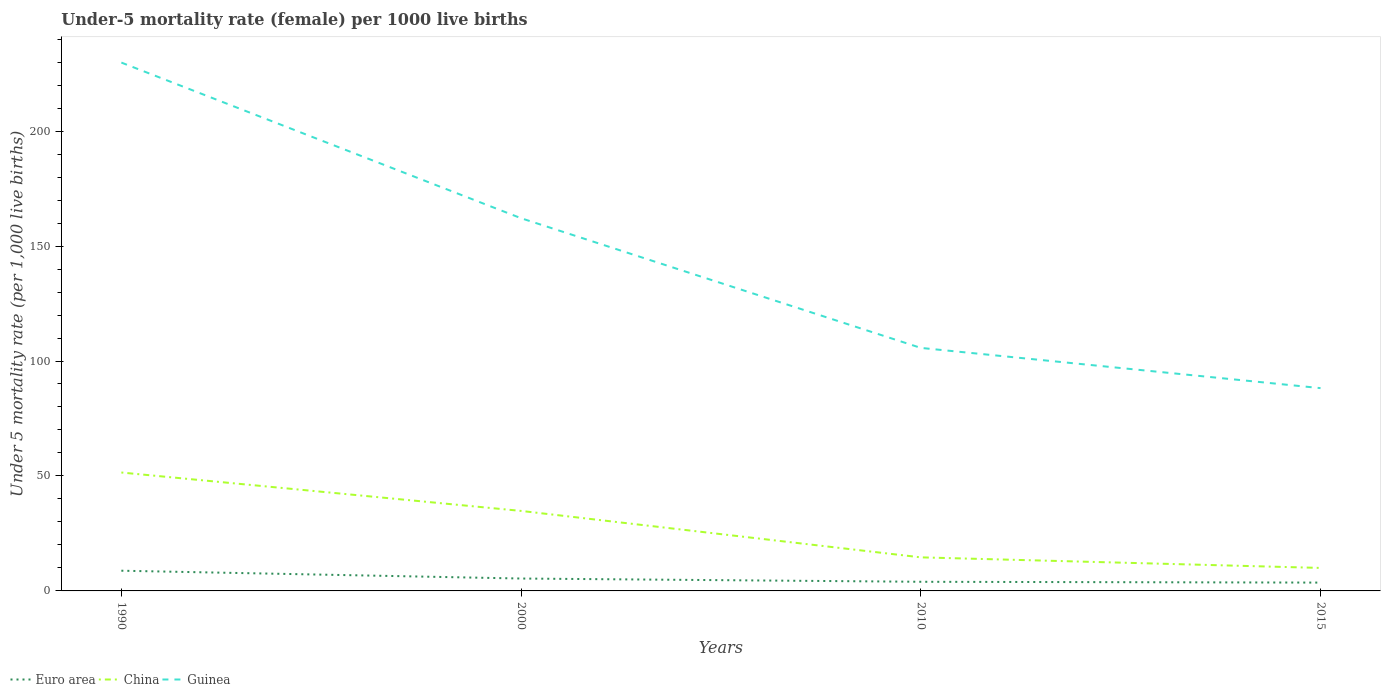How many different coloured lines are there?
Your answer should be very brief. 3. Is the number of lines equal to the number of legend labels?
Ensure brevity in your answer.  Yes. Across all years, what is the maximum under-five mortality rate in Guinea?
Your answer should be very brief. 88.2. In which year was the under-five mortality rate in China maximum?
Give a very brief answer. 2015. What is the total under-five mortality rate in Guinea in the graph?
Your response must be concise. 67.7. What is the difference between the highest and the second highest under-five mortality rate in China?
Give a very brief answer. 41.5. Does the graph contain grids?
Offer a terse response. No. Where does the legend appear in the graph?
Keep it short and to the point. Bottom left. How many legend labels are there?
Provide a succinct answer. 3. How are the legend labels stacked?
Make the answer very short. Horizontal. What is the title of the graph?
Keep it short and to the point. Under-5 mortality rate (female) per 1000 live births. What is the label or title of the X-axis?
Give a very brief answer. Years. What is the label or title of the Y-axis?
Your answer should be compact. Under 5 mortality rate (per 1,0 live births). What is the Under 5 mortality rate (per 1,000 live births) of Euro area in 1990?
Your answer should be very brief. 8.79. What is the Under 5 mortality rate (per 1,000 live births) of China in 1990?
Your answer should be very brief. 51.5. What is the Under 5 mortality rate (per 1,000 live births) of Guinea in 1990?
Offer a terse response. 229.8. What is the Under 5 mortality rate (per 1,000 live births) of Euro area in 2000?
Keep it short and to the point. 5.39. What is the Under 5 mortality rate (per 1,000 live births) in China in 2000?
Your response must be concise. 34.8. What is the Under 5 mortality rate (per 1,000 live births) of Guinea in 2000?
Your response must be concise. 162.1. What is the Under 5 mortality rate (per 1,000 live births) of Euro area in 2010?
Your answer should be compact. 3.97. What is the Under 5 mortality rate (per 1,000 live births) of Guinea in 2010?
Your answer should be compact. 105.7. What is the Under 5 mortality rate (per 1,000 live births) of Euro area in 2015?
Your answer should be very brief. 3.62. What is the Under 5 mortality rate (per 1,000 live births) of China in 2015?
Keep it short and to the point. 10. What is the Under 5 mortality rate (per 1,000 live births) of Guinea in 2015?
Provide a succinct answer. 88.2. Across all years, what is the maximum Under 5 mortality rate (per 1,000 live births) in Euro area?
Your answer should be very brief. 8.79. Across all years, what is the maximum Under 5 mortality rate (per 1,000 live births) in China?
Provide a succinct answer. 51.5. Across all years, what is the maximum Under 5 mortality rate (per 1,000 live births) of Guinea?
Make the answer very short. 229.8. Across all years, what is the minimum Under 5 mortality rate (per 1,000 live births) of Euro area?
Offer a very short reply. 3.62. Across all years, what is the minimum Under 5 mortality rate (per 1,000 live births) of China?
Ensure brevity in your answer.  10. Across all years, what is the minimum Under 5 mortality rate (per 1,000 live births) of Guinea?
Ensure brevity in your answer.  88.2. What is the total Under 5 mortality rate (per 1,000 live births) in Euro area in the graph?
Make the answer very short. 21.78. What is the total Under 5 mortality rate (per 1,000 live births) in China in the graph?
Ensure brevity in your answer.  110.9. What is the total Under 5 mortality rate (per 1,000 live births) in Guinea in the graph?
Offer a very short reply. 585.8. What is the difference between the Under 5 mortality rate (per 1,000 live births) in Euro area in 1990 and that in 2000?
Provide a succinct answer. 3.4. What is the difference between the Under 5 mortality rate (per 1,000 live births) of Guinea in 1990 and that in 2000?
Your answer should be very brief. 67.7. What is the difference between the Under 5 mortality rate (per 1,000 live births) of Euro area in 1990 and that in 2010?
Provide a short and direct response. 4.81. What is the difference between the Under 5 mortality rate (per 1,000 live births) in China in 1990 and that in 2010?
Your answer should be compact. 36.9. What is the difference between the Under 5 mortality rate (per 1,000 live births) of Guinea in 1990 and that in 2010?
Make the answer very short. 124.1. What is the difference between the Under 5 mortality rate (per 1,000 live births) in Euro area in 1990 and that in 2015?
Ensure brevity in your answer.  5.17. What is the difference between the Under 5 mortality rate (per 1,000 live births) of China in 1990 and that in 2015?
Offer a very short reply. 41.5. What is the difference between the Under 5 mortality rate (per 1,000 live births) of Guinea in 1990 and that in 2015?
Offer a terse response. 141.6. What is the difference between the Under 5 mortality rate (per 1,000 live births) of Euro area in 2000 and that in 2010?
Your answer should be compact. 1.42. What is the difference between the Under 5 mortality rate (per 1,000 live births) in China in 2000 and that in 2010?
Your answer should be very brief. 20.2. What is the difference between the Under 5 mortality rate (per 1,000 live births) of Guinea in 2000 and that in 2010?
Your response must be concise. 56.4. What is the difference between the Under 5 mortality rate (per 1,000 live births) of Euro area in 2000 and that in 2015?
Ensure brevity in your answer.  1.77. What is the difference between the Under 5 mortality rate (per 1,000 live births) of China in 2000 and that in 2015?
Make the answer very short. 24.8. What is the difference between the Under 5 mortality rate (per 1,000 live births) of Guinea in 2000 and that in 2015?
Your response must be concise. 73.9. What is the difference between the Under 5 mortality rate (per 1,000 live births) of Euro area in 2010 and that in 2015?
Make the answer very short. 0.35. What is the difference between the Under 5 mortality rate (per 1,000 live births) in Guinea in 2010 and that in 2015?
Give a very brief answer. 17.5. What is the difference between the Under 5 mortality rate (per 1,000 live births) of Euro area in 1990 and the Under 5 mortality rate (per 1,000 live births) of China in 2000?
Offer a terse response. -26.01. What is the difference between the Under 5 mortality rate (per 1,000 live births) in Euro area in 1990 and the Under 5 mortality rate (per 1,000 live births) in Guinea in 2000?
Provide a succinct answer. -153.31. What is the difference between the Under 5 mortality rate (per 1,000 live births) of China in 1990 and the Under 5 mortality rate (per 1,000 live births) of Guinea in 2000?
Provide a succinct answer. -110.6. What is the difference between the Under 5 mortality rate (per 1,000 live births) in Euro area in 1990 and the Under 5 mortality rate (per 1,000 live births) in China in 2010?
Offer a very short reply. -5.81. What is the difference between the Under 5 mortality rate (per 1,000 live births) in Euro area in 1990 and the Under 5 mortality rate (per 1,000 live births) in Guinea in 2010?
Provide a succinct answer. -96.91. What is the difference between the Under 5 mortality rate (per 1,000 live births) of China in 1990 and the Under 5 mortality rate (per 1,000 live births) of Guinea in 2010?
Give a very brief answer. -54.2. What is the difference between the Under 5 mortality rate (per 1,000 live births) in Euro area in 1990 and the Under 5 mortality rate (per 1,000 live births) in China in 2015?
Make the answer very short. -1.21. What is the difference between the Under 5 mortality rate (per 1,000 live births) in Euro area in 1990 and the Under 5 mortality rate (per 1,000 live births) in Guinea in 2015?
Your answer should be compact. -79.41. What is the difference between the Under 5 mortality rate (per 1,000 live births) in China in 1990 and the Under 5 mortality rate (per 1,000 live births) in Guinea in 2015?
Offer a terse response. -36.7. What is the difference between the Under 5 mortality rate (per 1,000 live births) in Euro area in 2000 and the Under 5 mortality rate (per 1,000 live births) in China in 2010?
Your answer should be compact. -9.21. What is the difference between the Under 5 mortality rate (per 1,000 live births) in Euro area in 2000 and the Under 5 mortality rate (per 1,000 live births) in Guinea in 2010?
Your response must be concise. -100.31. What is the difference between the Under 5 mortality rate (per 1,000 live births) of China in 2000 and the Under 5 mortality rate (per 1,000 live births) of Guinea in 2010?
Offer a very short reply. -70.9. What is the difference between the Under 5 mortality rate (per 1,000 live births) of Euro area in 2000 and the Under 5 mortality rate (per 1,000 live births) of China in 2015?
Provide a succinct answer. -4.61. What is the difference between the Under 5 mortality rate (per 1,000 live births) in Euro area in 2000 and the Under 5 mortality rate (per 1,000 live births) in Guinea in 2015?
Give a very brief answer. -82.81. What is the difference between the Under 5 mortality rate (per 1,000 live births) in China in 2000 and the Under 5 mortality rate (per 1,000 live births) in Guinea in 2015?
Offer a very short reply. -53.4. What is the difference between the Under 5 mortality rate (per 1,000 live births) in Euro area in 2010 and the Under 5 mortality rate (per 1,000 live births) in China in 2015?
Offer a very short reply. -6.03. What is the difference between the Under 5 mortality rate (per 1,000 live births) of Euro area in 2010 and the Under 5 mortality rate (per 1,000 live births) of Guinea in 2015?
Make the answer very short. -84.23. What is the difference between the Under 5 mortality rate (per 1,000 live births) in China in 2010 and the Under 5 mortality rate (per 1,000 live births) in Guinea in 2015?
Give a very brief answer. -73.6. What is the average Under 5 mortality rate (per 1,000 live births) in Euro area per year?
Provide a short and direct response. 5.44. What is the average Under 5 mortality rate (per 1,000 live births) in China per year?
Provide a succinct answer. 27.73. What is the average Under 5 mortality rate (per 1,000 live births) in Guinea per year?
Provide a short and direct response. 146.45. In the year 1990, what is the difference between the Under 5 mortality rate (per 1,000 live births) in Euro area and Under 5 mortality rate (per 1,000 live births) in China?
Your answer should be very brief. -42.71. In the year 1990, what is the difference between the Under 5 mortality rate (per 1,000 live births) of Euro area and Under 5 mortality rate (per 1,000 live births) of Guinea?
Your answer should be very brief. -221.01. In the year 1990, what is the difference between the Under 5 mortality rate (per 1,000 live births) of China and Under 5 mortality rate (per 1,000 live births) of Guinea?
Give a very brief answer. -178.3. In the year 2000, what is the difference between the Under 5 mortality rate (per 1,000 live births) of Euro area and Under 5 mortality rate (per 1,000 live births) of China?
Give a very brief answer. -29.41. In the year 2000, what is the difference between the Under 5 mortality rate (per 1,000 live births) in Euro area and Under 5 mortality rate (per 1,000 live births) in Guinea?
Offer a terse response. -156.71. In the year 2000, what is the difference between the Under 5 mortality rate (per 1,000 live births) of China and Under 5 mortality rate (per 1,000 live births) of Guinea?
Make the answer very short. -127.3. In the year 2010, what is the difference between the Under 5 mortality rate (per 1,000 live births) in Euro area and Under 5 mortality rate (per 1,000 live births) in China?
Give a very brief answer. -10.63. In the year 2010, what is the difference between the Under 5 mortality rate (per 1,000 live births) in Euro area and Under 5 mortality rate (per 1,000 live births) in Guinea?
Keep it short and to the point. -101.73. In the year 2010, what is the difference between the Under 5 mortality rate (per 1,000 live births) of China and Under 5 mortality rate (per 1,000 live births) of Guinea?
Offer a terse response. -91.1. In the year 2015, what is the difference between the Under 5 mortality rate (per 1,000 live births) of Euro area and Under 5 mortality rate (per 1,000 live births) of China?
Give a very brief answer. -6.38. In the year 2015, what is the difference between the Under 5 mortality rate (per 1,000 live births) of Euro area and Under 5 mortality rate (per 1,000 live births) of Guinea?
Your response must be concise. -84.58. In the year 2015, what is the difference between the Under 5 mortality rate (per 1,000 live births) in China and Under 5 mortality rate (per 1,000 live births) in Guinea?
Your response must be concise. -78.2. What is the ratio of the Under 5 mortality rate (per 1,000 live births) in Euro area in 1990 to that in 2000?
Your answer should be very brief. 1.63. What is the ratio of the Under 5 mortality rate (per 1,000 live births) of China in 1990 to that in 2000?
Offer a very short reply. 1.48. What is the ratio of the Under 5 mortality rate (per 1,000 live births) in Guinea in 1990 to that in 2000?
Give a very brief answer. 1.42. What is the ratio of the Under 5 mortality rate (per 1,000 live births) in Euro area in 1990 to that in 2010?
Your answer should be compact. 2.21. What is the ratio of the Under 5 mortality rate (per 1,000 live births) of China in 1990 to that in 2010?
Provide a succinct answer. 3.53. What is the ratio of the Under 5 mortality rate (per 1,000 live births) in Guinea in 1990 to that in 2010?
Your answer should be compact. 2.17. What is the ratio of the Under 5 mortality rate (per 1,000 live births) in Euro area in 1990 to that in 2015?
Keep it short and to the point. 2.43. What is the ratio of the Under 5 mortality rate (per 1,000 live births) of China in 1990 to that in 2015?
Offer a very short reply. 5.15. What is the ratio of the Under 5 mortality rate (per 1,000 live births) of Guinea in 1990 to that in 2015?
Provide a short and direct response. 2.61. What is the ratio of the Under 5 mortality rate (per 1,000 live births) of Euro area in 2000 to that in 2010?
Offer a terse response. 1.36. What is the ratio of the Under 5 mortality rate (per 1,000 live births) in China in 2000 to that in 2010?
Offer a terse response. 2.38. What is the ratio of the Under 5 mortality rate (per 1,000 live births) in Guinea in 2000 to that in 2010?
Your response must be concise. 1.53. What is the ratio of the Under 5 mortality rate (per 1,000 live births) of Euro area in 2000 to that in 2015?
Ensure brevity in your answer.  1.49. What is the ratio of the Under 5 mortality rate (per 1,000 live births) of China in 2000 to that in 2015?
Provide a succinct answer. 3.48. What is the ratio of the Under 5 mortality rate (per 1,000 live births) in Guinea in 2000 to that in 2015?
Provide a short and direct response. 1.84. What is the ratio of the Under 5 mortality rate (per 1,000 live births) of Euro area in 2010 to that in 2015?
Provide a succinct answer. 1.1. What is the ratio of the Under 5 mortality rate (per 1,000 live births) in China in 2010 to that in 2015?
Your response must be concise. 1.46. What is the ratio of the Under 5 mortality rate (per 1,000 live births) in Guinea in 2010 to that in 2015?
Offer a very short reply. 1.2. What is the difference between the highest and the second highest Under 5 mortality rate (per 1,000 live births) of Euro area?
Give a very brief answer. 3.4. What is the difference between the highest and the second highest Under 5 mortality rate (per 1,000 live births) of Guinea?
Provide a succinct answer. 67.7. What is the difference between the highest and the lowest Under 5 mortality rate (per 1,000 live births) in Euro area?
Give a very brief answer. 5.17. What is the difference between the highest and the lowest Under 5 mortality rate (per 1,000 live births) in China?
Ensure brevity in your answer.  41.5. What is the difference between the highest and the lowest Under 5 mortality rate (per 1,000 live births) in Guinea?
Ensure brevity in your answer.  141.6. 